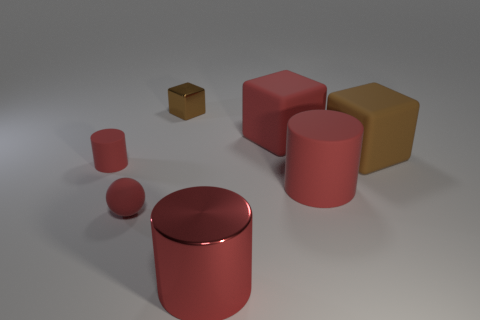Subtract 1 blocks. How many blocks are left? 2 Add 1 brown rubber cubes. How many objects exist? 8 Subtract all cylinders. How many objects are left? 4 Subtract all cyan rubber spheres. Subtract all brown cubes. How many objects are left? 5 Add 6 tiny rubber spheres. How many tiny rubber spheres are left? 7 Add 3 cylinders. How many cylinders exist? 6 Subtract 0 purple cylinders. How many objects are left? 7 